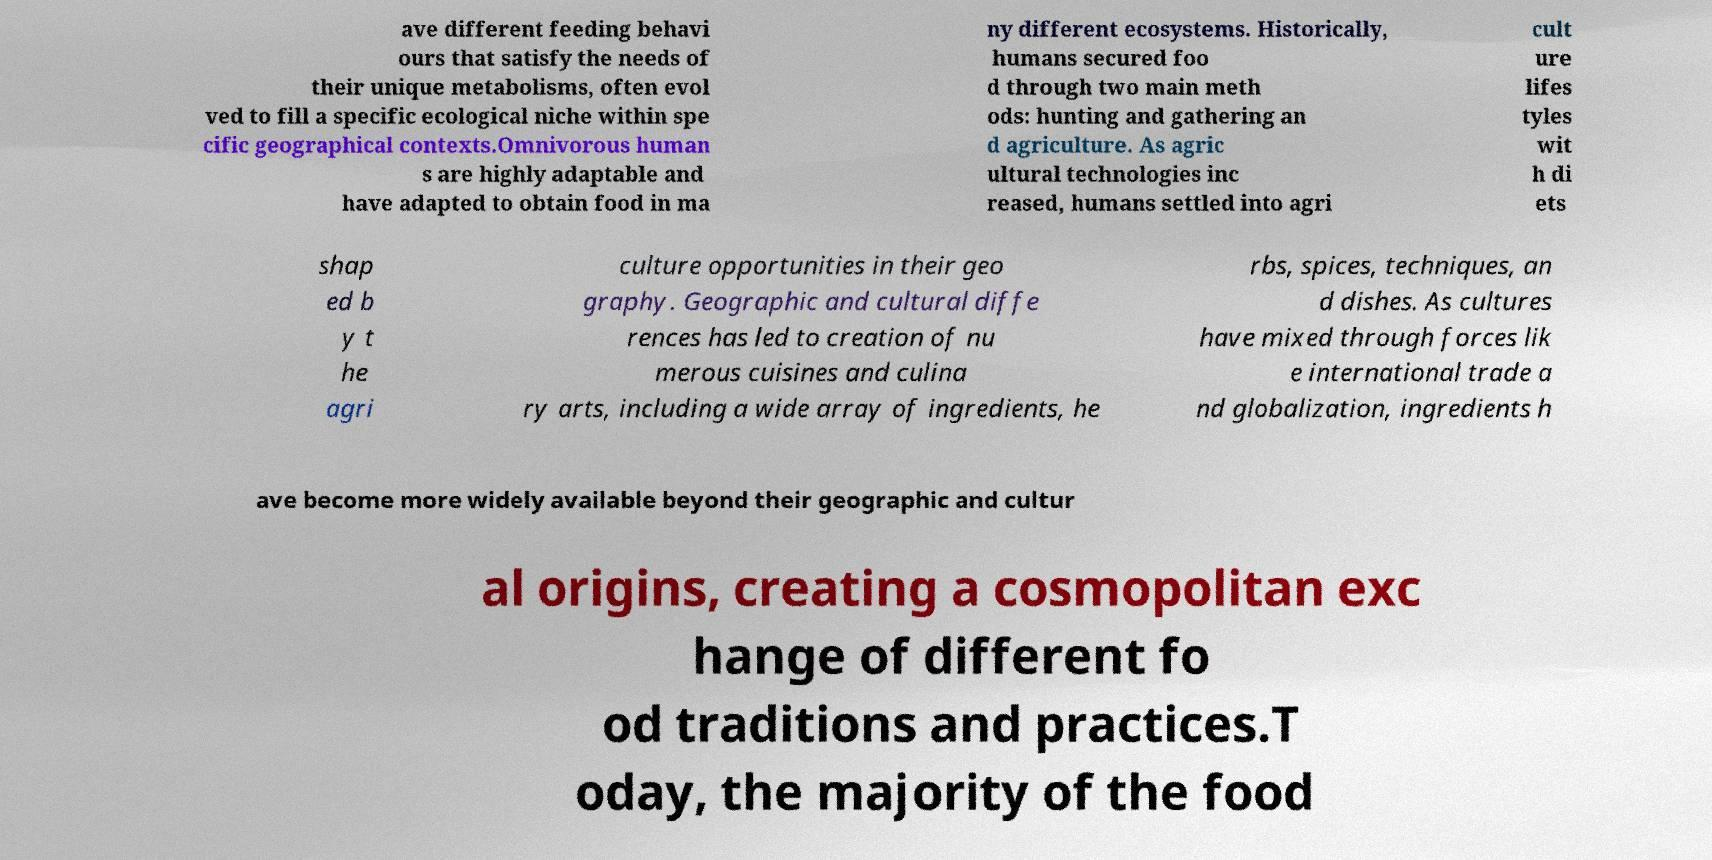There's text embedded in this image that I need extracted. Can you transcribe it verbatim? ave different feeding behavi ours that satisfy the needs of their unique metabolisms, often evol ved to fill a specific ecological niche within spe cific geographical contexts.Omnivorous human s are highly adaptable and have adapted to obtain food in ma ny different ecosystems. Historically, humans secured foo d through two main meth ods: hunting and gathering an d agriculture. As agric ultural technologies inc reased, humans settled into agri cult ure lifes tyles wit h di ets shap ed b y t he agri culture opportunities in their geo graphy. Geographic and cultural diffe rences has led to creation of nu merous cuisines and culina ry arts, including a wide array of ingredients, he rbs, spices, techniques, an d dishes. As cultures have mixed through forces lik e international trade a nd globalization, ingredients h ave become more widely available beyond their geographic and cultur al origins, creating a cosmopolitan exc hange of different fo od traditions and practices.T oday, the majority of the food 